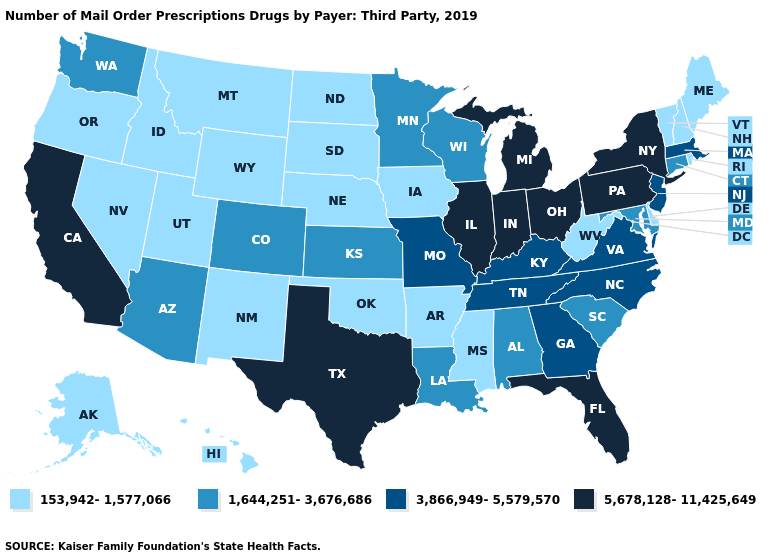What is the value of Nevada?
Concise answer only. 153,942-1,577,066. Name the states that have a value in the range 3,866,949-5,579,570?
Keep it brief. Georgia, Kentucky, Massachusetts, Missouri, New Jersey, North Carolina, Tennessee, Virginia. What is the highest value in the USA?
Write a very short answer. 5,678,128-11,425,649. Among the states that border Mississippi , does Arkansas have the highest value?
Concise answer only. No. What is the value of South Dakota?
Concise answer only. 153,942-1,577,066. Does Texas have the lowest value in the USA?
Write a very short answer. No. Among the states that border Delaware , which have the lowest value?
Keep it brief. Maryland. Name the states that have a value in the range 1,644,251-3,676,686?
Write a very short answer. Alabama, Arizona, Colorado, Connecticut, Kansas, Louisiana, Maryland, Minnesota, South Carolina, Washington, Wisconsin. What is the value of Tennessee?
Answer briefly. 3,866,949-5,579,570. What is the lowest value in the South?
Short answer required. 153,942-1,577,066. What is the value of California?
Concise answer only. 5,678,128-11,425,649. Name the states that have a value in the range 3,866,949-5,579,570?
Be succinct. Georgia, Kentucky, Massachusetts, Missouri, New Jersey, North Carolina, Tennessee, Virginia. What is the value of Virginia?
Give a very brief answer. 3,866,949-5,579,570. Does the first symbol in the legend represent the smallest category?
Keep it brief. Yes. Which states hav the highest value in the Northeast?
Write a very short answer. New York, Pennsylvania. 